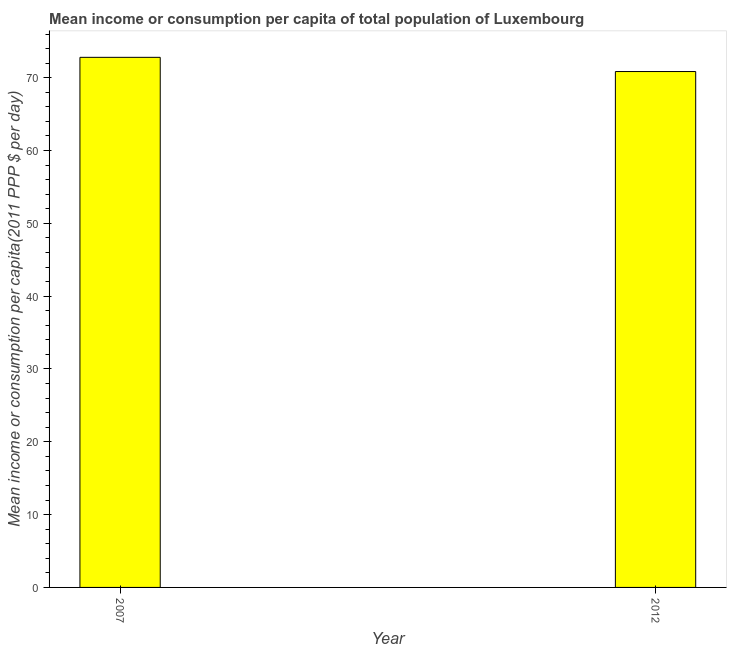Does the graph contain any zero values?
Provide a short and direct response. No. What is the title of the graph?
Provide a succinct answer. Mean income or consumption per capita of total population of Luxembourg. What is the label or title of the X-axis?
Offer a terse response. Year. What is the label or title of the Y-axis?
Give a very brief answer. Mean income or consumption per capita(2011 PPP $ per day). What is the mean income or consumption in 2007?
Give a very brief answer. 72.8. Across all years, what is the maximum mean income or consumption?
Keep it short and to the point. 72.8. Across all years, what is the minimum mean income or consumption?
Your answer should be compact. 70.85. In which year was the mean income or consumption minimum?
Your answer should be very brief. 2012. What is the sum of the mean income or consumption?
Provide a succinct answer. 143.65. What is the difference between the mean income or consumption in 2007 and 2012?
Your response must be concise. 1.95. What is the average mean income or consumption per year?
Give a very brief answer. 71.83. What is the median mean income or consumption?
Ensure brevity in your answer.  71.82. Do a majority of the years between 2007 and 2012 (inclusive) have mean income or consumption greater than 48 $?
Ensure brevity in your answer.  Yes. What is the ratio of the mean income or consumption in 2007 to that in 2012?
Offer a terse response. 1.03. Is the mean income or consumption in 2007 less than that in 2012?
Offer a very short reply. No. In how many years, is the mean income or consumption greater than the average mean income or consumption taken over all years?
Provide a succinct answer. 1. Are all the bars in the graph horizontal?
Give a very brief answer. No. What is the difference between two consecutive major ticks on the Y-axis?
Provide a succinct answer. 10. Are the values on the major ticks of Y-axis written in scientific E-notation?
Keep it short and to the point. No. What is the Mean income or consumption per capita(2011 PPP $ per day) of 2007?
Your answer should be compact. 72.8. What is the Mean income or consumption per capita(2011 PPP $ per day) of 2012?
Ensure brevity in your answer.  70.85. What is the difference between the Mean income or consumption per capita(2011 PPP $ per day) in 2007 and 2012?
Your answer should be very brief. 1.95. What is the ratio of the Mean income or consumption per capita(2011 PPP $ per day) in 2007 to that in 2012?
Your response must be concise. 1.03. 